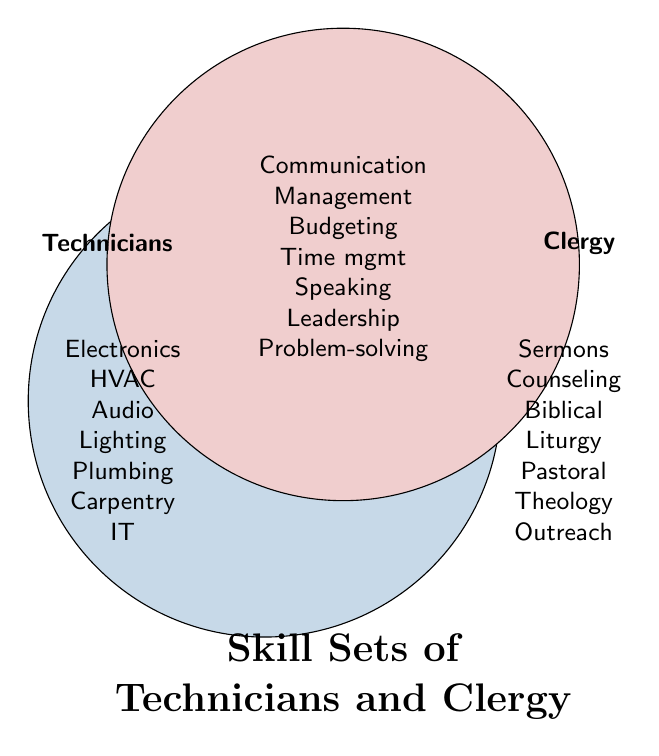How many skills are unique to technicians? Count the items in the technicians' section of the Venn diagram. There are seven: Electronics troubleshooting, HVAC maintenance, Audio system operation, Lighting control, Plumbing repairs, Carpentry, IT support.
Answer: Seven How many skills are shared by both technicians and clergy? Count the items in the overlapping section of the Venn diagram. There are seven: Communication skills, Project management, Budgeting, Time management, Public speaking, Team leadership, Problem-solving.
Answer: Seven Which skill is unique to clergy but related to knowledge? Look at the clergy section and identify the skills related to knowledge. "Biblical knowledge" fits this description.
Answer: Biblical knowledge Are technicians' skills more focused on physical tasks than clergy's? Review the specific skills listed for both groups. Technicians have skills like Electronics troubleshooting, HVAC maintenance, Audio system operation, Lighting control, Plumbing repairs, Carpentry, IT support which involve physical tasks. Clergy skills are more about spiritual and community guidance like Sermon preparation, Spiritual counseling, Biblical knowledge, Liturgical planning, Pastoral care, Theological research, Community outreach.
Answer: Yes Which role has more skills listed, technicians or clergy? Count the skills listed under each circle separately. Both technicians and clergy have seven unique skills listed.
Answer: Equal What skills could facilitate both technicians and clergy in managing teams? Look at the overlapping section of the Venn diagram. Skills like Communication skills, Project management, Time management, Team leadership are helpful in managing teams.
Answer: Communication skills, Project management, Time management, Team leadership Do clergy have more skills related to communication than technicians? Identify and count communication-related skills. Clergy have Sermon preparation, Spiritual counseling, Pastoral care, Community outreach which are directly related to communication. Technicians have Communication skills in the overlapping section.
Answer: Yes What shared skill could help both technicians and clergy manage budgets effectively? Look at the overlapping section where shared skills are listed. "Budgeting" is directly related to managing budgets.
Answer: Budgeting How many total skills are displayed on the Venn diagram? Count all unique and shared skills listed in both circles. There are seven unique to technicians, seven unique to clergy, and seven shared, adding up to 21 in total.
Answer: 21 